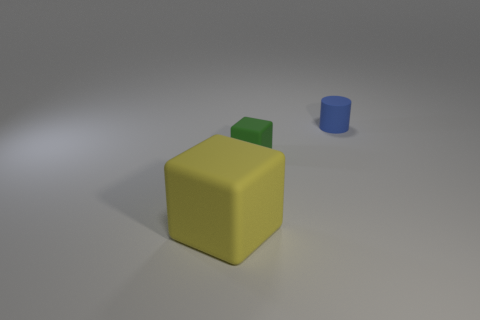Are there any other things that are the same size as the green matte thing?
Ensure brevity in your answer.  Yes. What size is the other thing that is the same shape as the large object?
Keep it short and to the point. Small. Are there the same number of tiny blue matte cylinders that are behind the tiny blue thing and big yellow rubber cubes that are to the left of the yellow rubber object?
Provide a short and direct response. Yes. There is a block in front of the small green block; how big is it?
Keep it short and to the point. Large. Do the small matte block and the cylinder have the same color?
Offer a terse response. No. Is there any other thing that is the same shape as the green object?
Your response must be concise. Yes. Are there the same number of big objects that are on the right side of the matte cylinder and blue metallic blocks?
Your answer should be very brief. Yes. There is a large yellow matte block; are there any cubes right of it?
Provide a succinct answer. Yes. There is a small green matte object; is its shape the same as the thing left of the small green cube?
Keep it short and to the point. Yes. There is a big block that is made of the same material as the blue object; what is its color?
Make the answer very short. Yellow. 